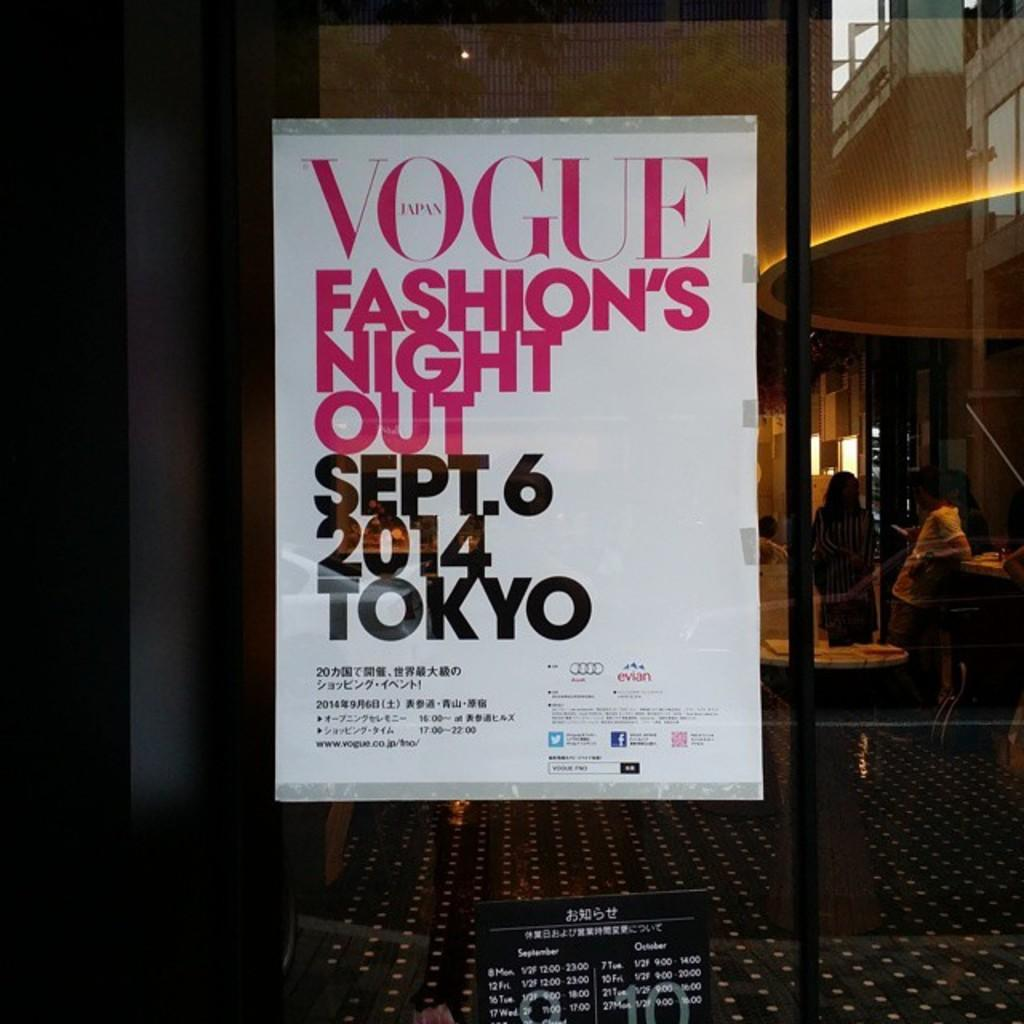<image>
Offer a succinct explanation of the picture presented. A poster advertises a fashion event sponsored by Vogue. 